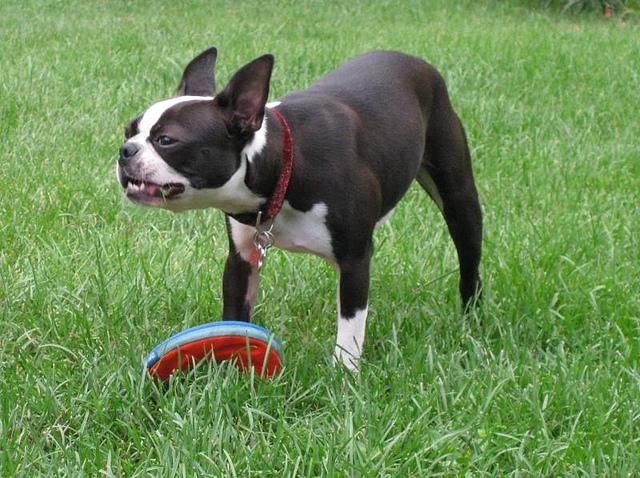Did the dog just catch a frisbee?
Quick response, please. Yes. Does this dog have tags?
Give a very brief answer. Yes. What kind of dog is that?
Be succinct. Bulldog. Does this dog look friendly?
Quick response, please. No. What is the dog holding?
Write a very short answer. Nothing. 